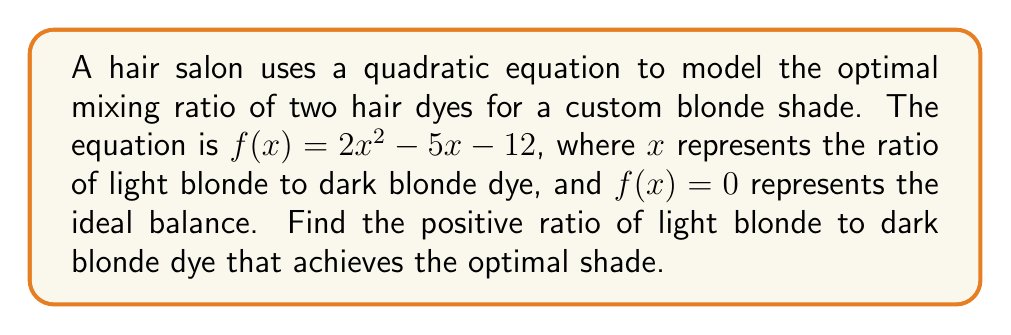Can you solve this math problem? To solve this problem, we need to factor the quadratic equation and find its roots:

1) The quadratic equation is $f(x) = 2x^2 - 5x - 12 = 0$

2) We can factor this equation using the ac-method:
   $a = 2$, $b = -5$, $c = -12$
   $ac = 2 * (-12) = -24$

3) Find two numbers that multiply to give -24 and add to give -5:
   These numbers are 3 and -8

4) Rewrite the middle term using these numbers:
   $2x^2 + 3x - 8x - 12 = 0$

5) Group the terms:
   $(2x^2 + 3x) + (-8x - 12) = 0$

6) Factor out the common factors from each group:
   $x(2x + 3) - 4(2x + 3) = 0$

7) Factor out the common binomial:
   $(2x + 3)(x - 4) = 0$

8) Set each factor to zero and solve:
   $2x + 3 = 0$ or $x - 4 = 0$
   $x = -\frac{3}{2}$ or $x = 4$

9) Since we're looking for the ratio of light blonde to dark blonde dye, we need a positive solution. Therefore, $x = 4$ is our answer.

This means the optimal ratio is 4 parts light blonde dye to 1 part dark blonde dye.
Answer: 4:1 